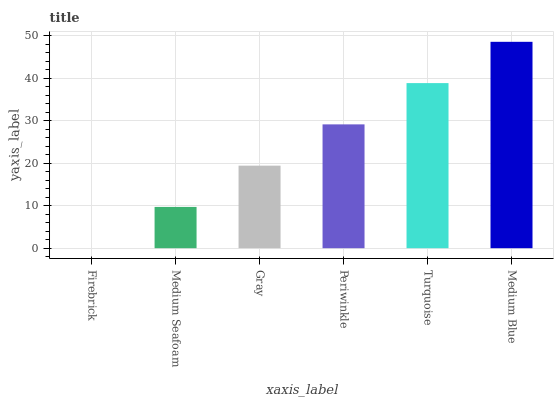Is Firebrick the minimum?
Answer yes or no. Yes. Is Medium Blue the maximum?
Answer yes or no. Yes. Is Medium Seafoam the minimum?
Answer yes or no. No. Is Medium Seafoam the maximum?
Answer yes or no. No. Is Medium Seafoam greater than Firebrick?
Answer yes or no. Yes. Is Firebrick less than Medium Seafoam?
Answer yes or no. Yes. Is Firebrick greater than Medium Seafoam?
Answer yes or no. No. Is Medium Seafoam less than Firebrick?
Answer yes or no. No. Is Periwinkle the high median?
Answer yes or no. Yes. Is Gray the low median?
Answer yes or no. Yes. Is Turquoise the high median?
Answer yes or no. No. Is Firebrick the low median?
Answer yes or no. No. 